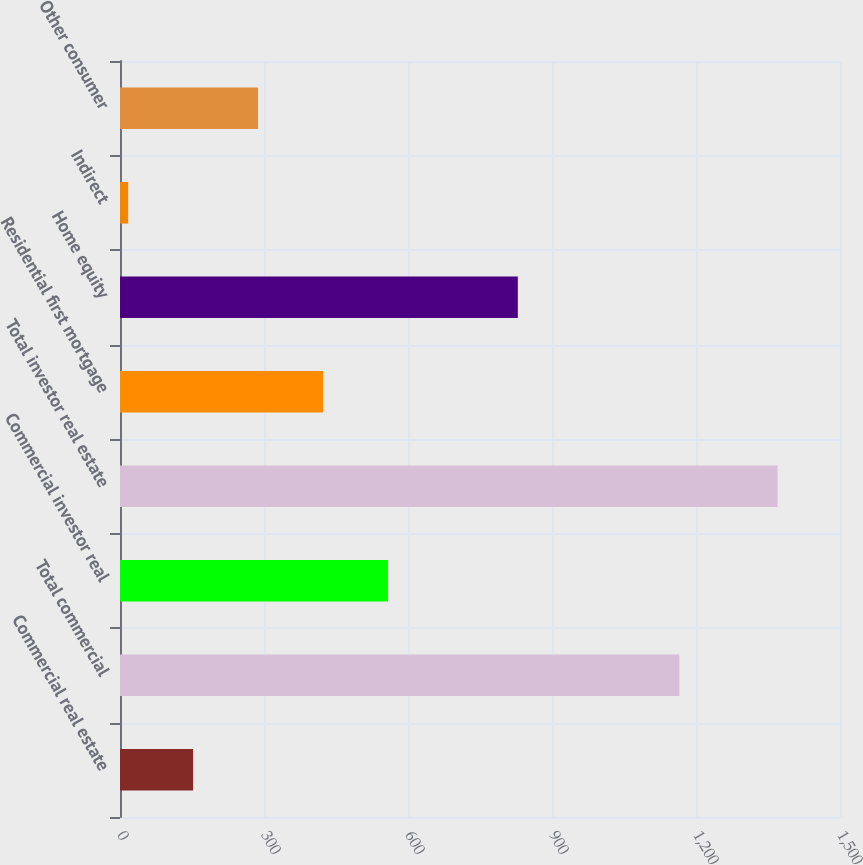<chart> <loc_0><loc_0><loc_500><loc_500><bar_chart><fcel>Commercial real estate<fcel>Total commercial<fcel>Commercial investor real<fcel>Total investor real estate<fcel>Residential first mortgage<fcel>Home equity<fcel>Indirect<fcel>Other consumer<nl><fcel>152.3<fcel>1165.3<fcel>558.2<fcel>1370<fcel>422.9<fcel>828.8<fcel>17<fcel>287.6<nl></chart> 